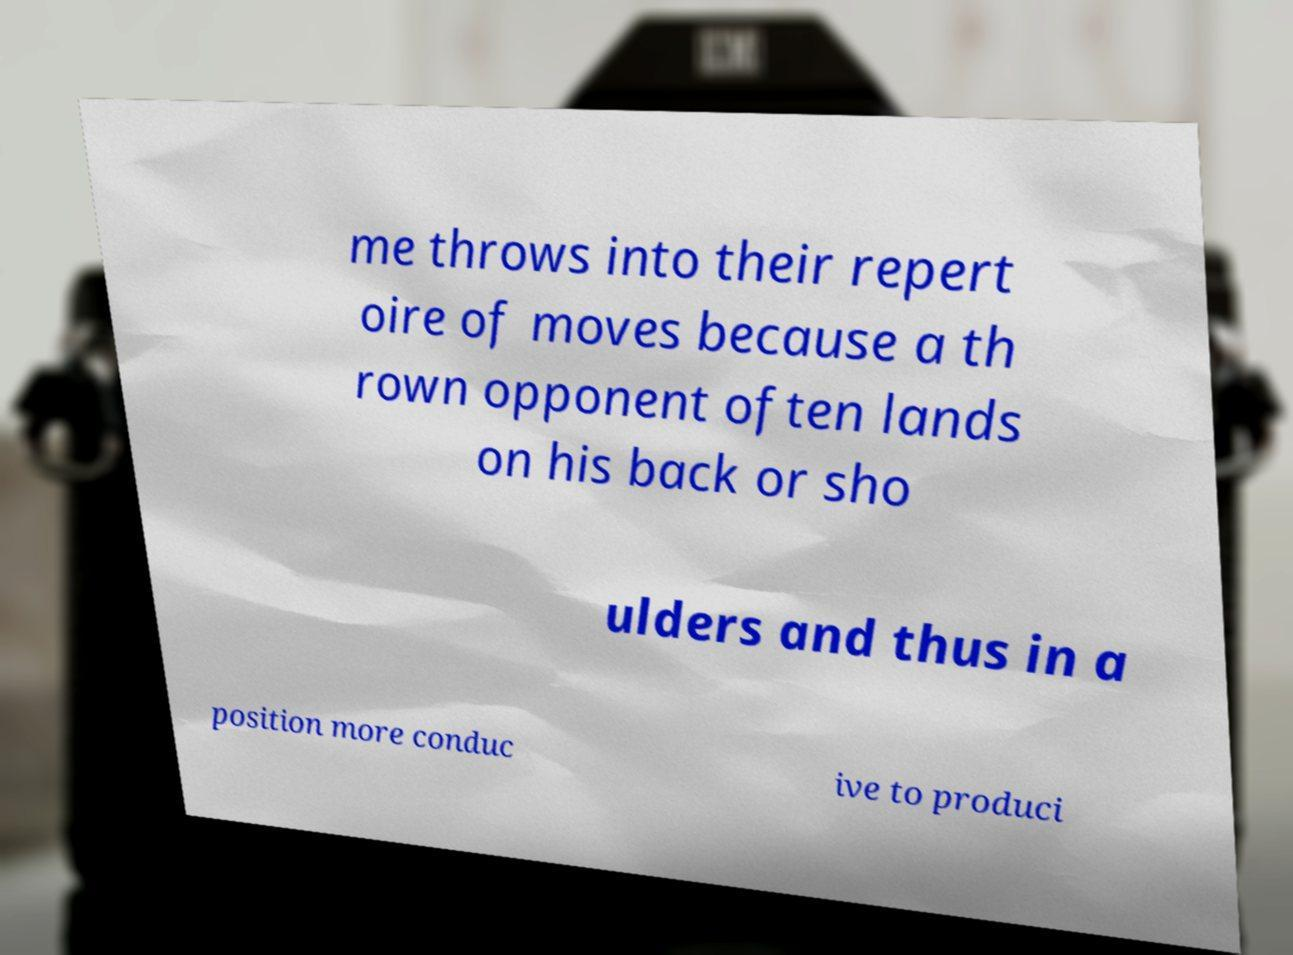Please identify and transcribe the text found in this image. me throws into their repert oire of moves because a th rown opponent often lands on his back or sho ulders and thus in a position more conduc ive to produci 